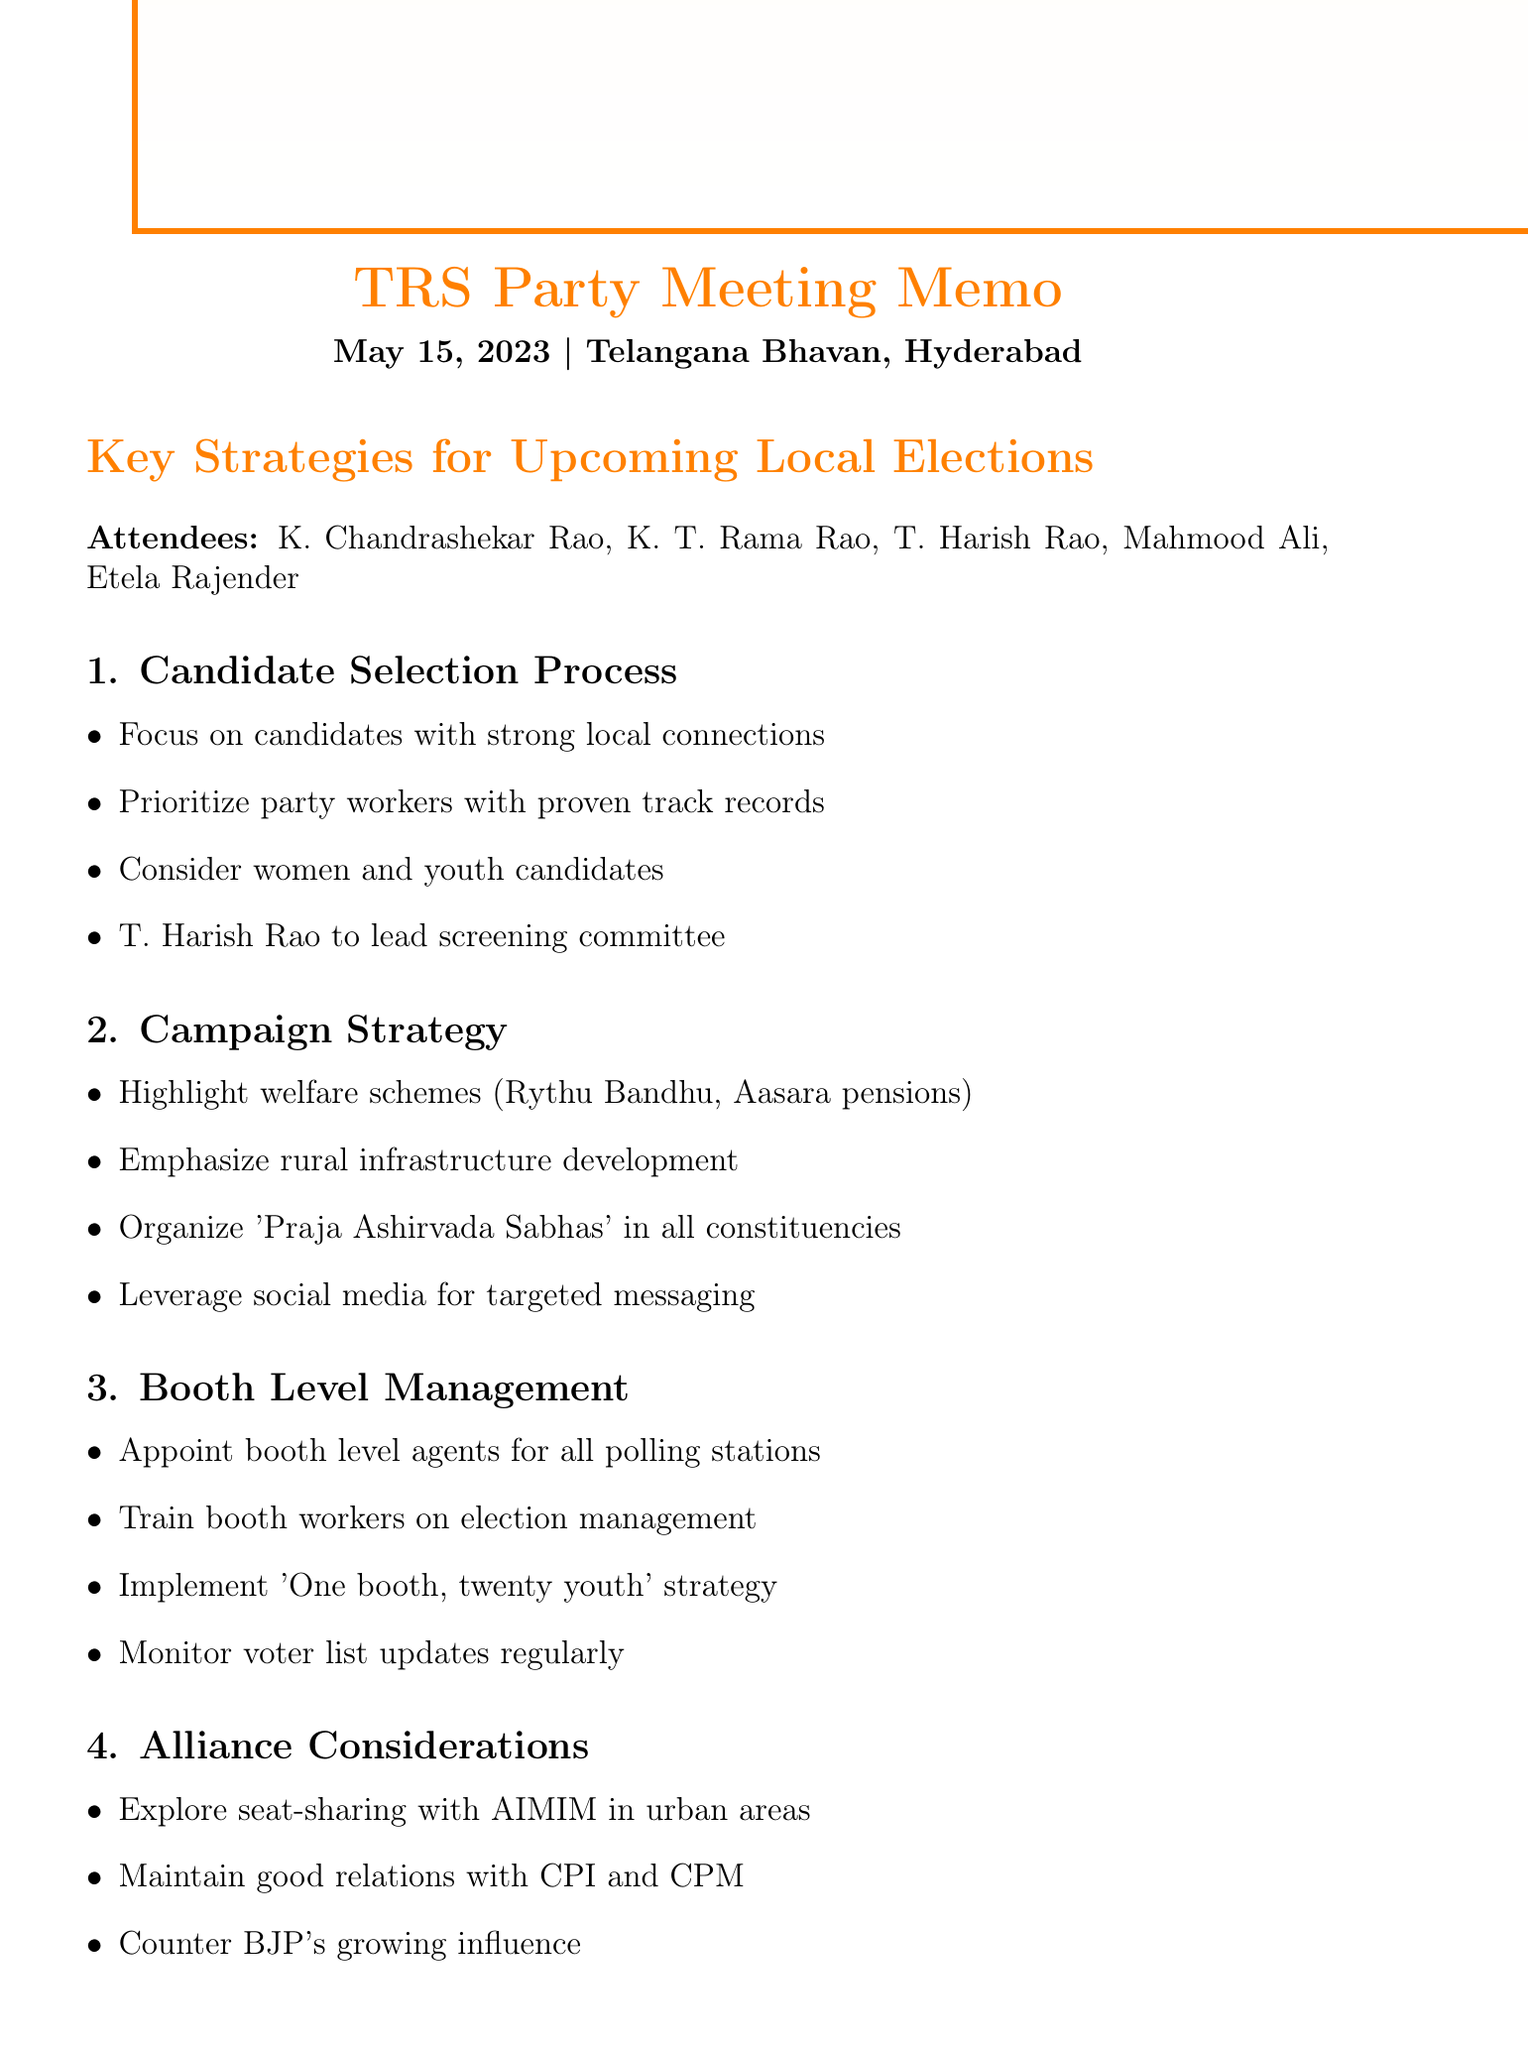What is the date of the meeting? The meeting took place on May 15, 2023, as noted in the document.
Answer: May 15, 2023 Who is leading the screening committee for candidate selection? T. Harish Rao is specifically mentioned as the head of the screening committee.
Answer: T. Harish Rao What is the focus of the campaign strategy? The campaign strategy emphasizes welfare schemes, rural infrastructure, and social media targeting among others.
Answer: Welfare schemes and rural infrastructure What is the candidate list finalization date? The candidate list finalization date is mentioned as June 1, 2023.
Answer: June 1, 2023 How many people are listed as attendees? The document lists five attendees from the TRS party meeting.
Answer: Five What is the 'One booth, twenty youth' strategy? This strategy aims to appoint youth at booth levels to strengthen management during elections.
Answer: Appointing youth at booth levels Which political party is mentioned for potential alliance in urban areas? AIMIM is referred to for potential seat-sharing arrangements in urban areas.
Answer: AIMIM What is the budget provision for campaign materials? The memo specifies a budget for local language campaign materials as part of resource allocation.
Answer: Local language campaign materials When does the first phase of local elections occur? The document states that the first phase of local elections is scheduled for July 20, 2023.
Answer: July 20, 2023 